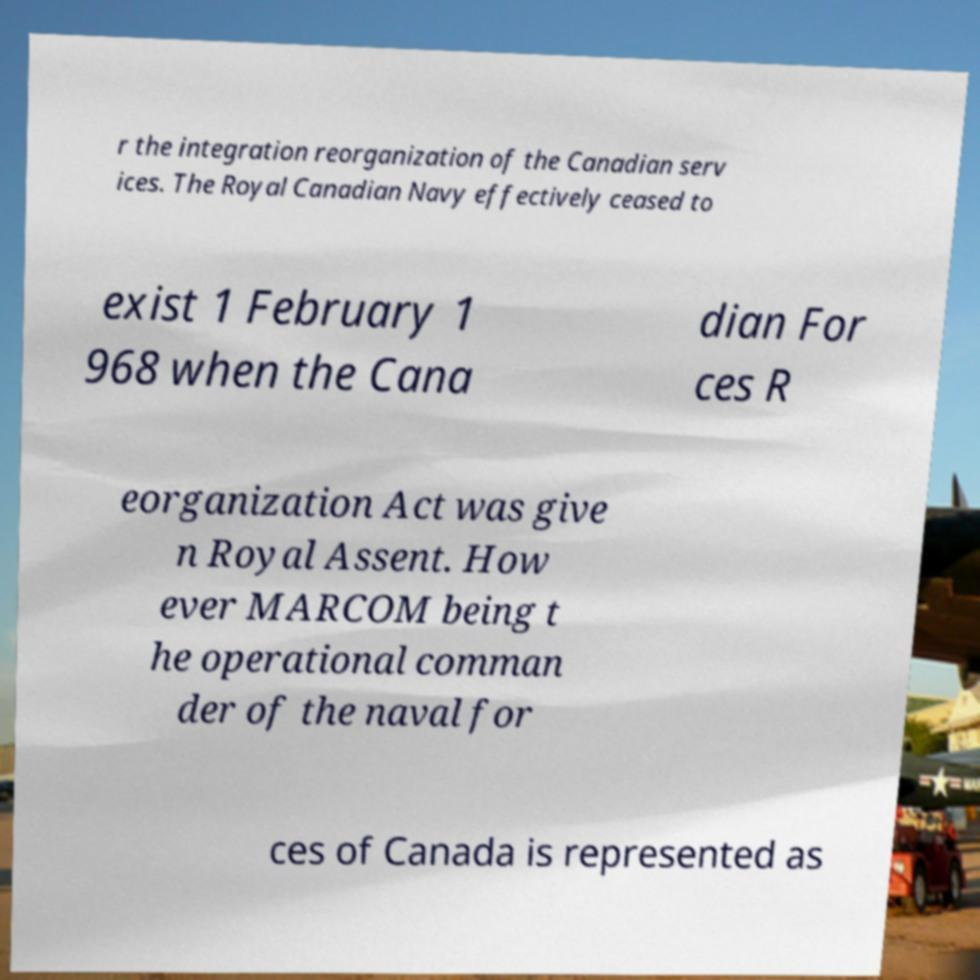What messages or text are displayed in this image? I need them in a readable, typed format. r the integration reorganization of the Canadian serv ices. The Royal Canadian Navy effectively ceased to exist 1 February 1 968 when the Cana dian For ces R eorganization Act was give n Royal Assent. How ever MARCOM being t he operational comman der of the naval for ces of Canada is represented as 